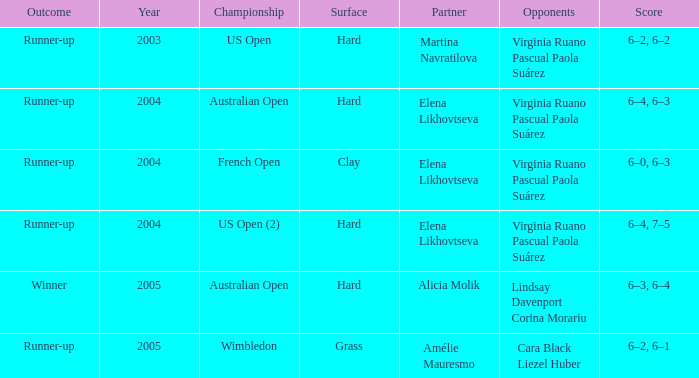For the australian open championship, which year is the most ancient? 2004.0. 